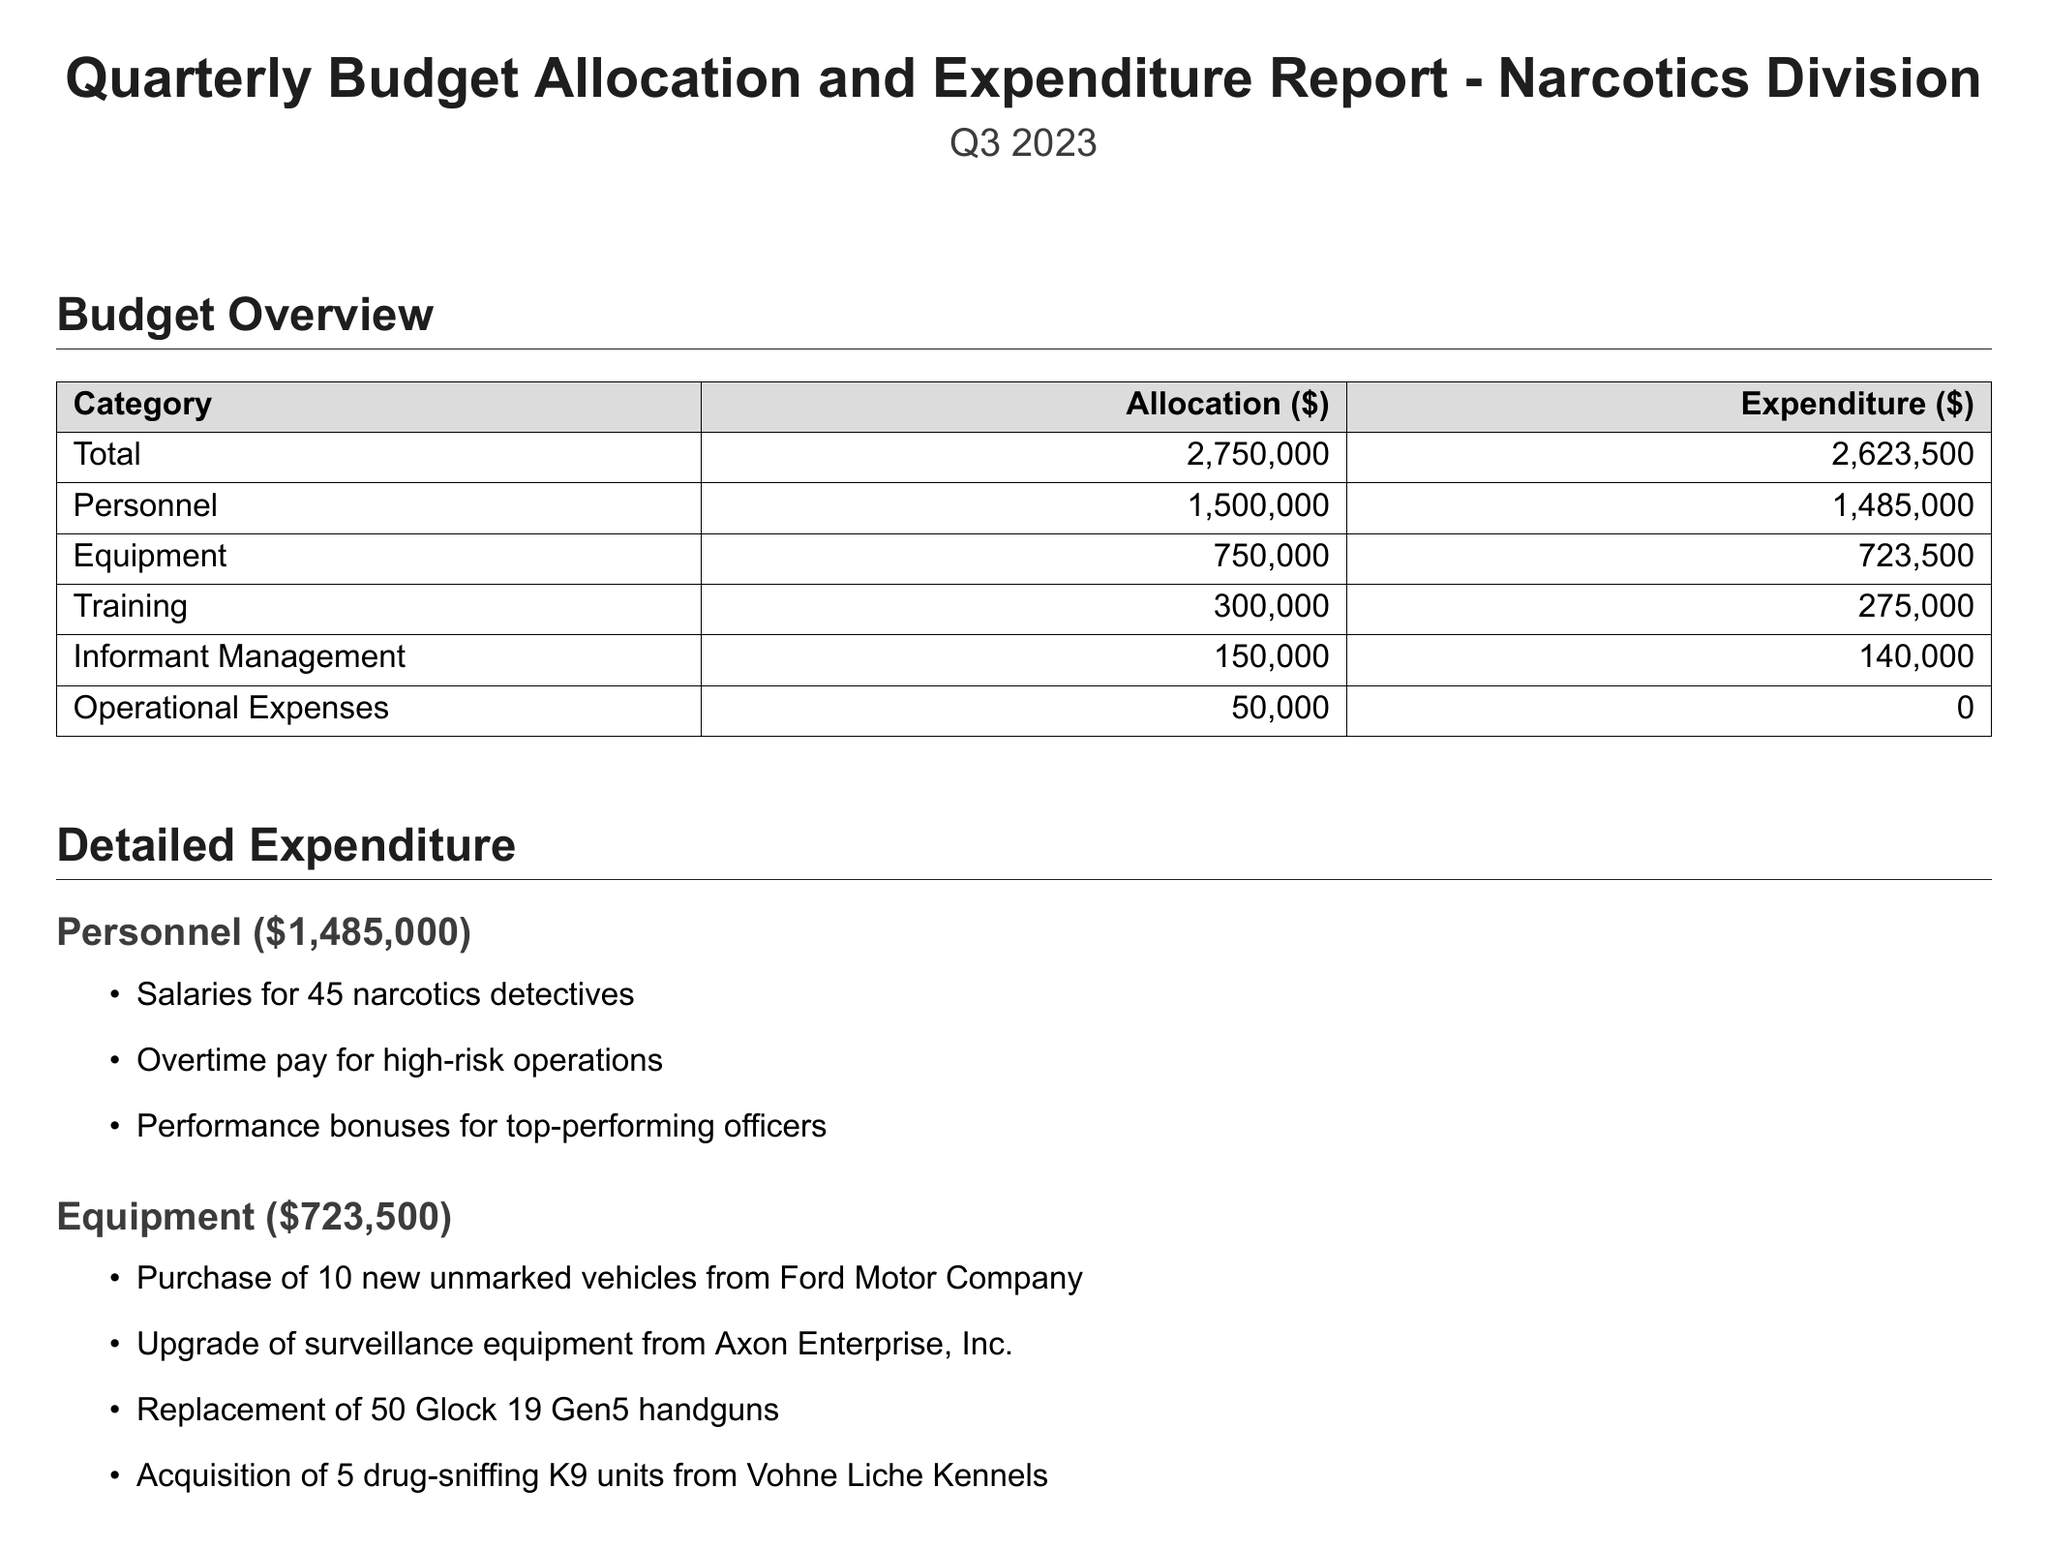What is the total budget for the narcotics division? The total budget is stated in the report as $2,750,000.
Answer: $2,750,000 What is the expenditure on personnel? The expenditure on personnel is provided in the budget sections and amounts to $1,485,000.
Answer: $1,485,000 How much was allocated for training? The report specifies that $300,000 was allocated for training.
Answer: $300,000 What is the target for successful prosecutions? The target for successful prosecutions is detailed in the key performance indicators as 80.
Answer: 80 What was the actual value of drug seizures? The report indicates that the actual value of drug seizures is $12,500,000.
Answer: $12,500,000 Which company provided the new vehicles? The report mentions that Ford Motor Company supplied the unmarked vehicles.
Answer: Ford Motor Company What challenge is related to drug trafficking networks? The report identifies the increasing sophistication of drug trafficking networks as a challenge.
Answer: Increasing sophistication of drug trafficking networks How many undercover operations were completed? The report shows that 18 undercover operations were completed, exceeding the target.
Answer: 18 What is one recommended action to improve prosecution rates? The report recommends reviewing and optimizing the case preparation process as an action to improve prosecution rates.
Answer: Review and optimize the case preparation process 